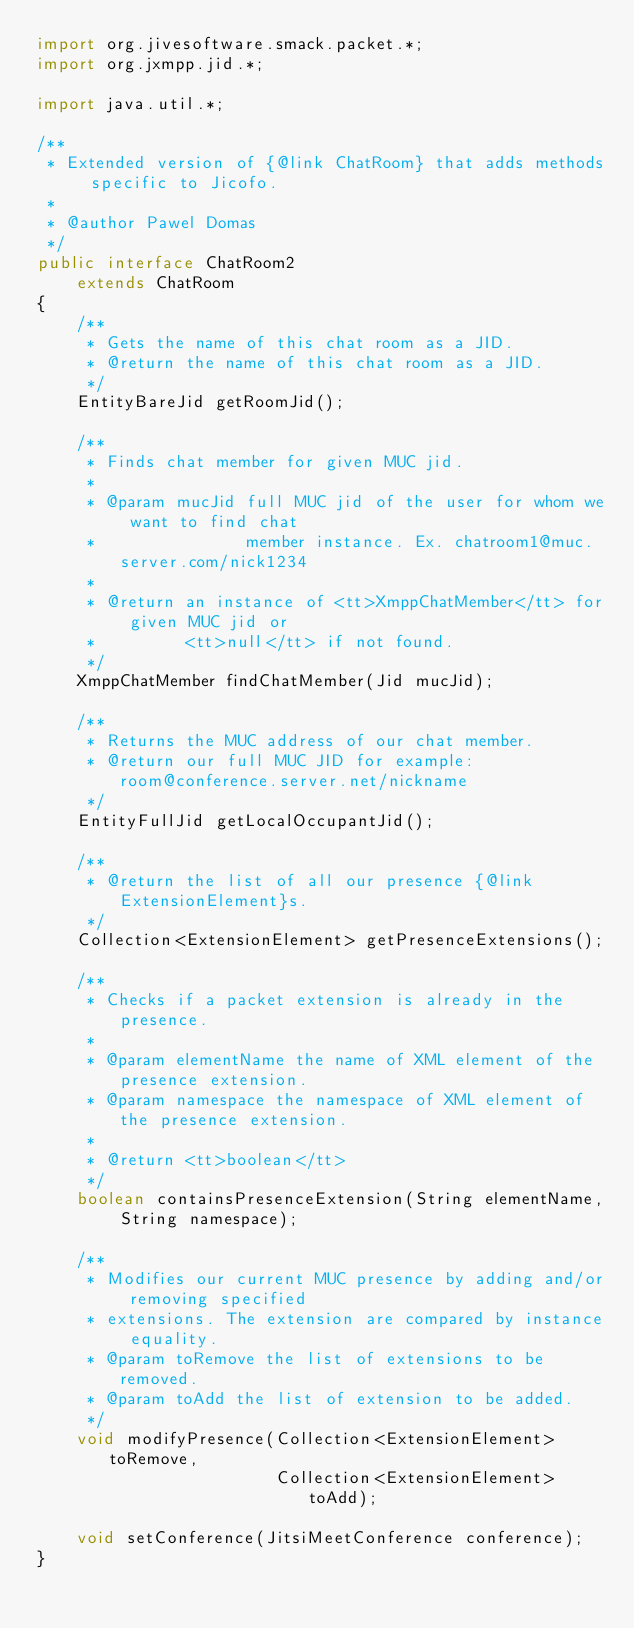<code> <loc_0><loc_0><loc_500><loc_500><_Java_>import org.jivesoftware.smack.packet.*;
import org.jxmpp.jid.*;

import java.util.*;

/**
 * Extended version of {@link ChatRoom} that adds methods specific to Jicofo.
 *
 * @author Pawel Domas
 */
public interface ChatRoom2
    extends ChatRoom
{
    /**
     * Gets the name of this chat room as a JID.
     * @return the name of this chat room as a JID.
     */
    EntityBareJid getRoomJid();

    /**
     * Finds chat member for given MUC jid.
     *
     * @param mucJid full MUC jid of the user for whom we want to find chat
     *               member instance. Ex. chatroom1@muc.server.com/nick1234
     *
     * @return an instance of <tt>XmppChatMember</tt> for given MUC jid or
     *         <tt>null</tt> if not found.
     */
    XmppChatMember findChatMember(Jid mucJid);

    /**
     * Returns the MUC address of our chat member.
     * @return our full MUC JID for example: room@conference.server.net/nickname
     */
    EntityFullJid getLocalOccupantJid();

    /**
     * @return the list of all our presence {@link ExtensionElement}s.
     */
    Collection<ExtensionElement> getPresenceExtensions();

    /**
     * Checks if a packet extension is already in the presence.
     *
     * @param elementName the name of XML element of the presence extension.
     * @param namespace the namespace of XML element of the presence extension.
     *
     * @return <tt>boolean</tt>
     */
    boolean containsPresenceExtension(String elementName, String namespace);

    /**
     * Modifies our current MUC presence by adding and/or removing specified
     * extensions. The extension are compared by instance equality.
     * @param toRemove the list of extensions to be removed.
     * @param toAdd the list of extension to be added.
     */
    void modifyPresence(Collection<ExtensionElement> toRemove,
                        Collection<ExtensionElement> toAdd);

    void setConference(JitsiMeetConference conference);
}
</code> 